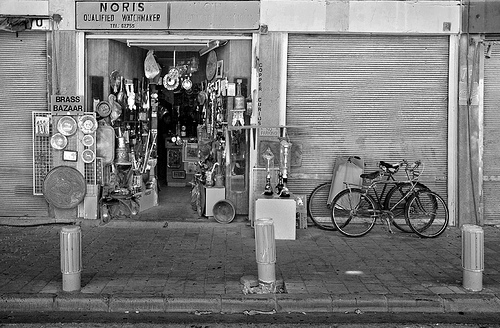How many trucks are shown? There are no trucks visible in the image, which showcases a storefront with various items displayed, including brass objects, and two bicycles parked outside. 